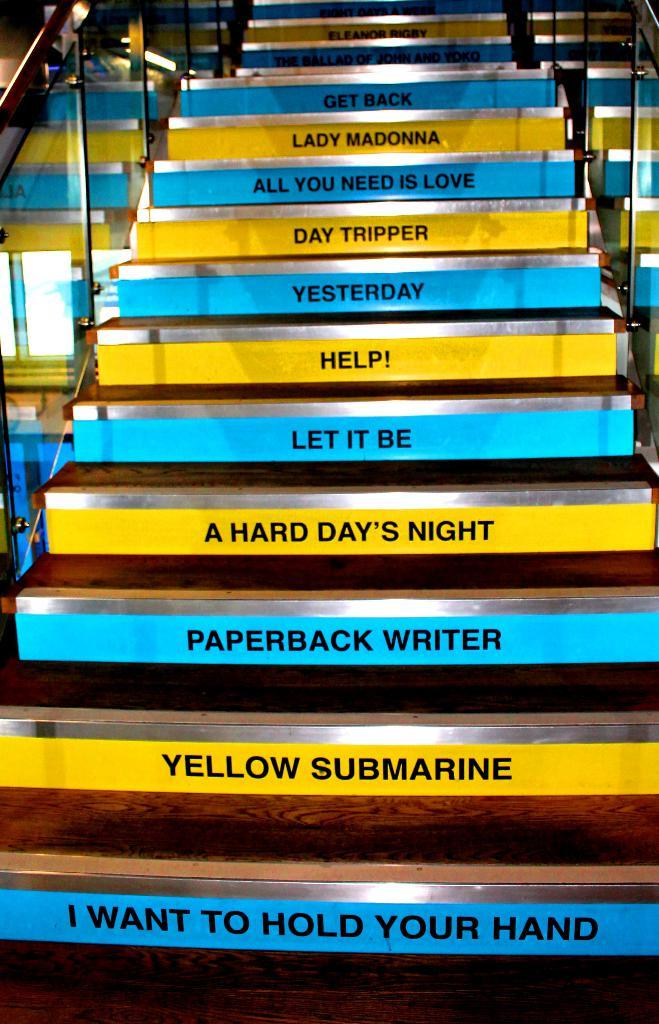<image>
Render a clear and concise summary of the photo. Yellow and blue steps have titles of Beatles songs on them, such as "Let it Be." 